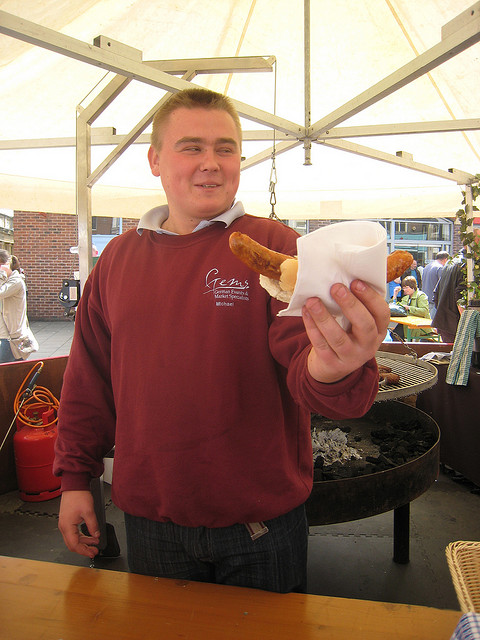Please identify all text content in this image. Gems 